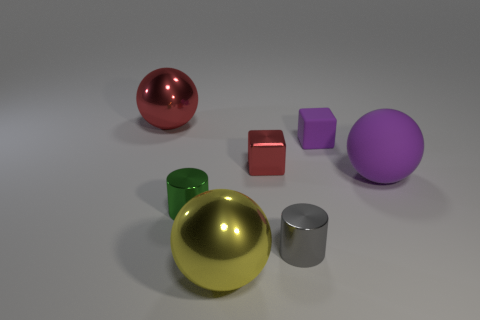How many small green things have the same material as the large red object?
Your response must be concise. 1. Do the large object that is on the left side of the large yellow object and the small purple object have the same material?
Offer a terse response. No. Is the number of metal blocks in front of the tiny purple thing greater than the number of gray metal things that are behind the yellow metal thing?
Make the answer very short. No. There is a purple object that is the same size as the gray cylinder; what material is it?
Provide a succinct answer. Rubber. How many other things are there of the same material as the tiny purple block?
Provide a short and direct response. 1. Is the shape of the tiny shiny thing that is to the right of the small red block the same as the green thing on the left side of the gray object?
Offer a very short reply. Yes. What number of other things are the same color as the big rubber object?
Your response must be concise. 1. Is the big thing behind the large purple matte sphere made of the same material as the big ball on the right side of the yellow shiny object?
Make the answer very short. No. Are there an equal number of matte balls that are to the left of the small gray thing and purple rubber things behind the big purple sphere?
Keep it short and to the point. No. There is a tiny block to the right of the shiny block; what is it made of?
Your answer should be very brief. Rubber. 